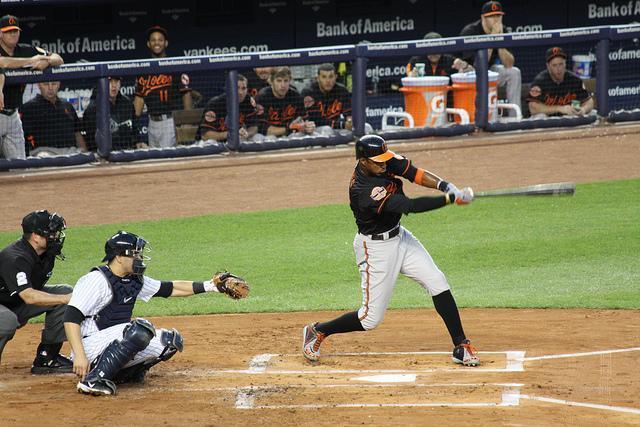How many people are there?
Give a very brief answer. 12. 